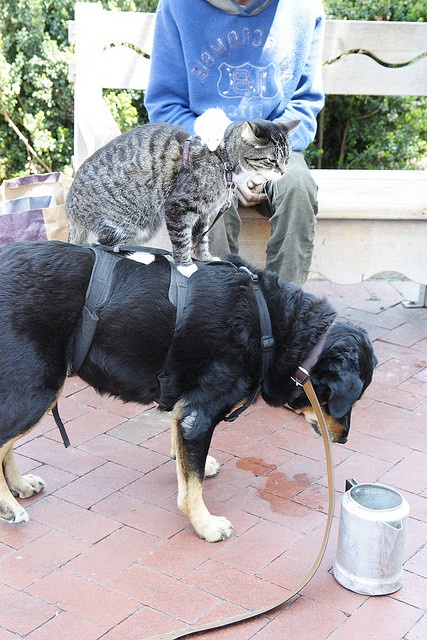Describe the objects in this image and their specific colors. I can see dog in darkgray, black, gray, and darkblue tones, people in darkgray, gray, and white tones, bench in darkgray, white, gray, and black tones, cat in darkgray, gray, lightgray, and black tones, and cup in darkgray, lavender, and lightblue tones in this image. 